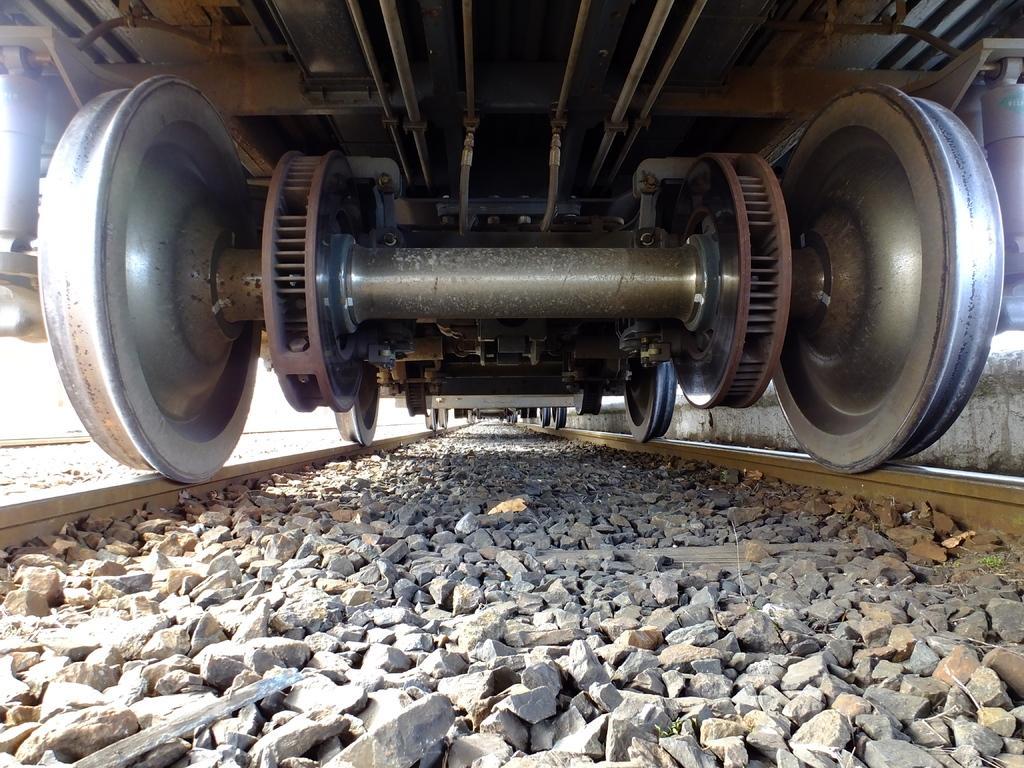Could you give a brief overview of what you see in this image? In this image there is a train on the tracks, we can see there are some stones at the middle of tracks. 